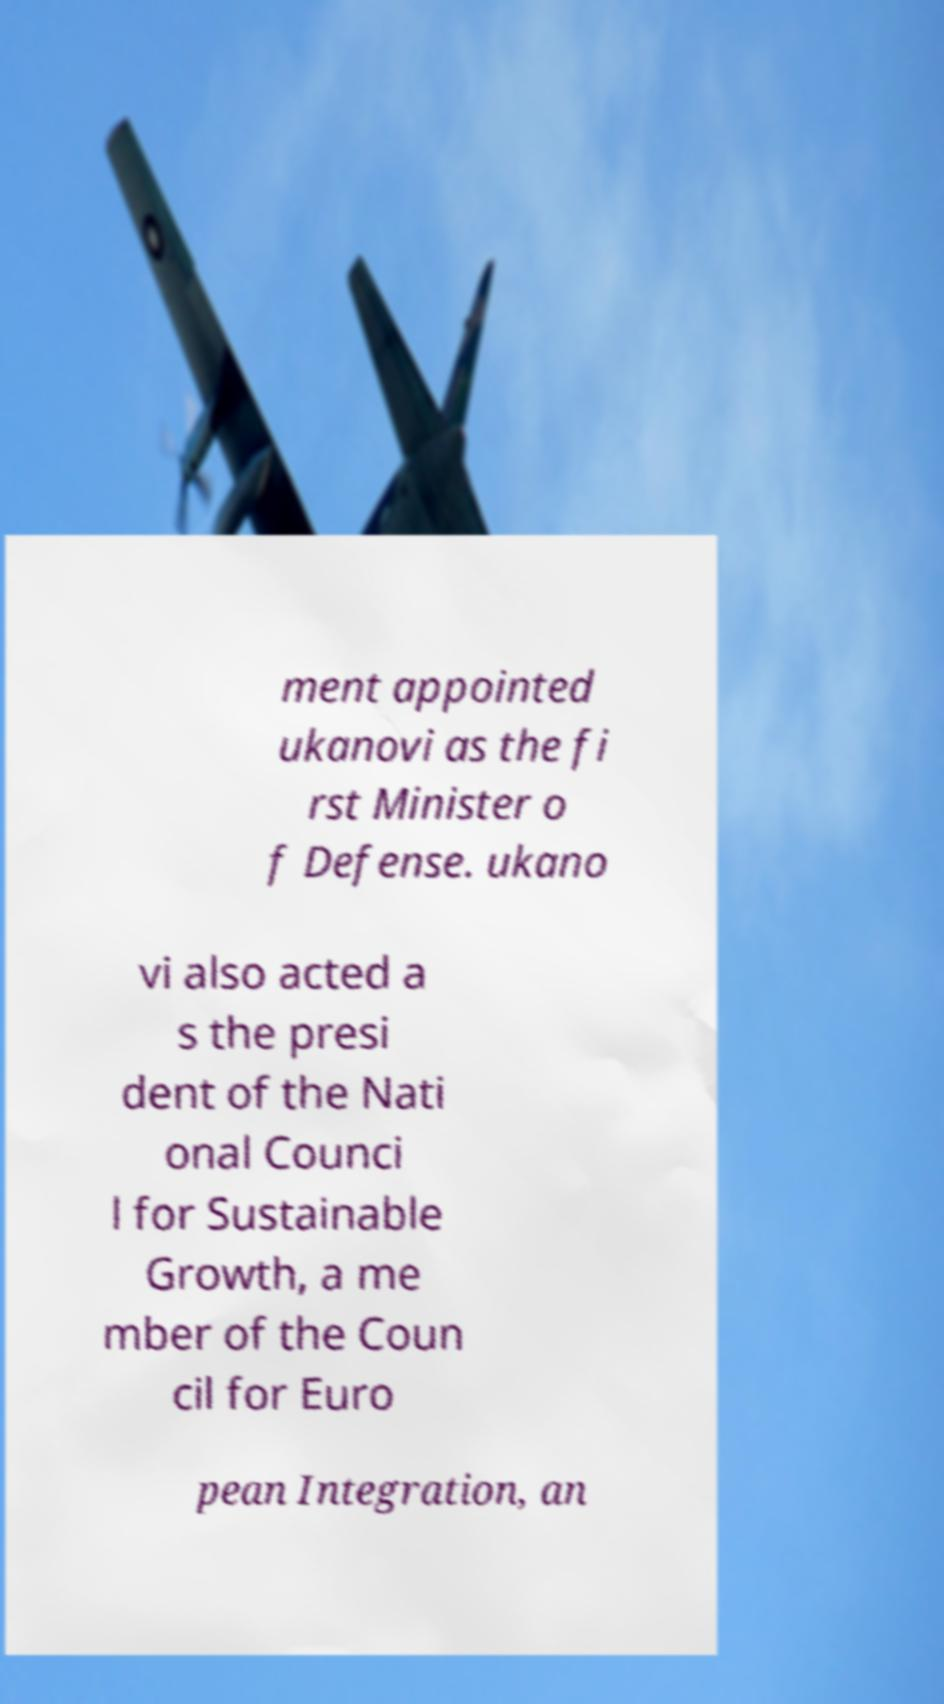Could you assist in decoding the text presented in this image and type it out clearly? ment appointed ukanovi as the fi rst Minister o f Defense. ukano vi also acted a s the presi dent of the Nati onal Counci l for Sustainable Growth, a me mber of the Coun cil for Euro pean Integration, an 